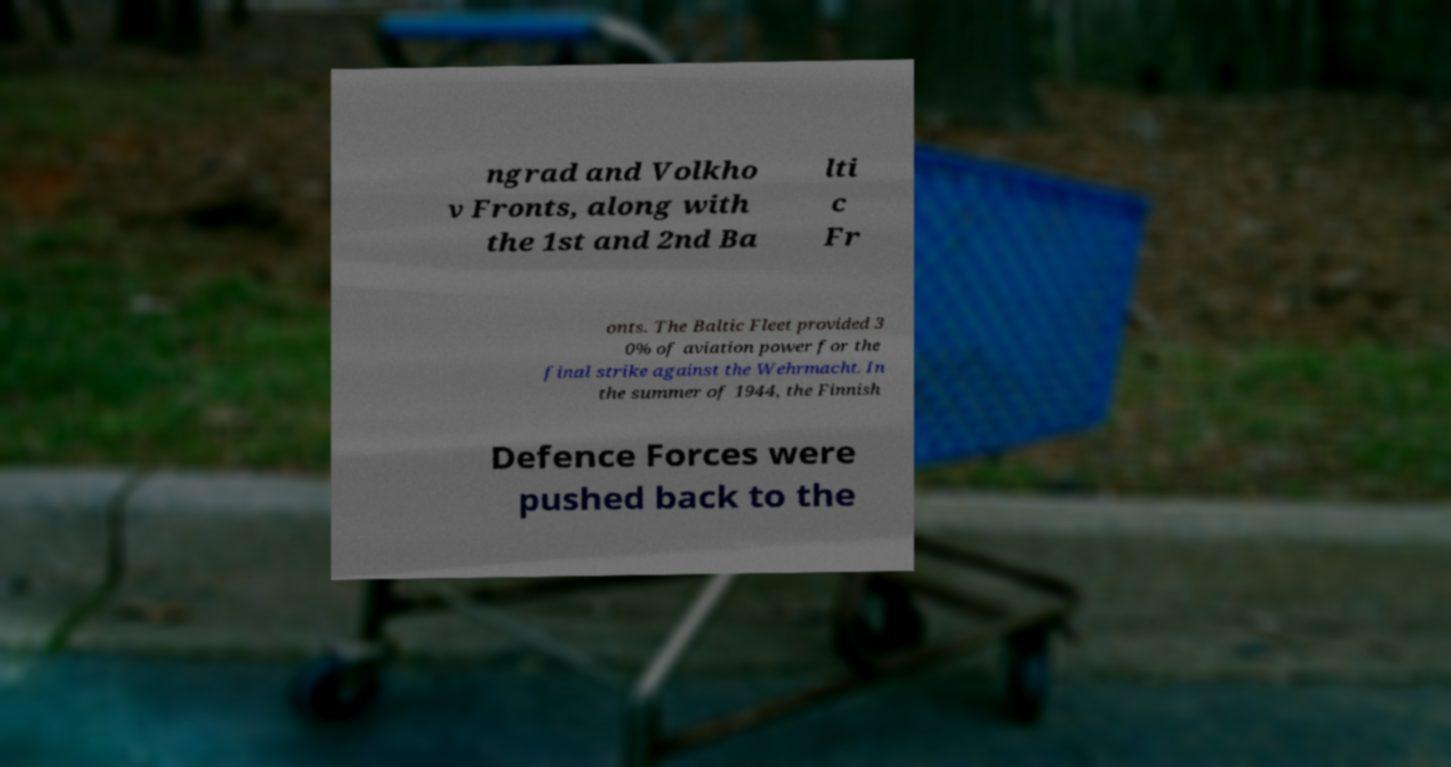Can you read and provide the text displayed in the image?This photo seems to have some interesting text. Can you extract and type it out for me? ngrad and Volkho v Fronts, along with the 1st and 2nd Ba lti c Fr onts. The Baltic Fleet provided 3 0% of aviation power for the final strike against the Wehrmacht. In the summer of 1944, the Finnish Defence Forces were pushed back to the 